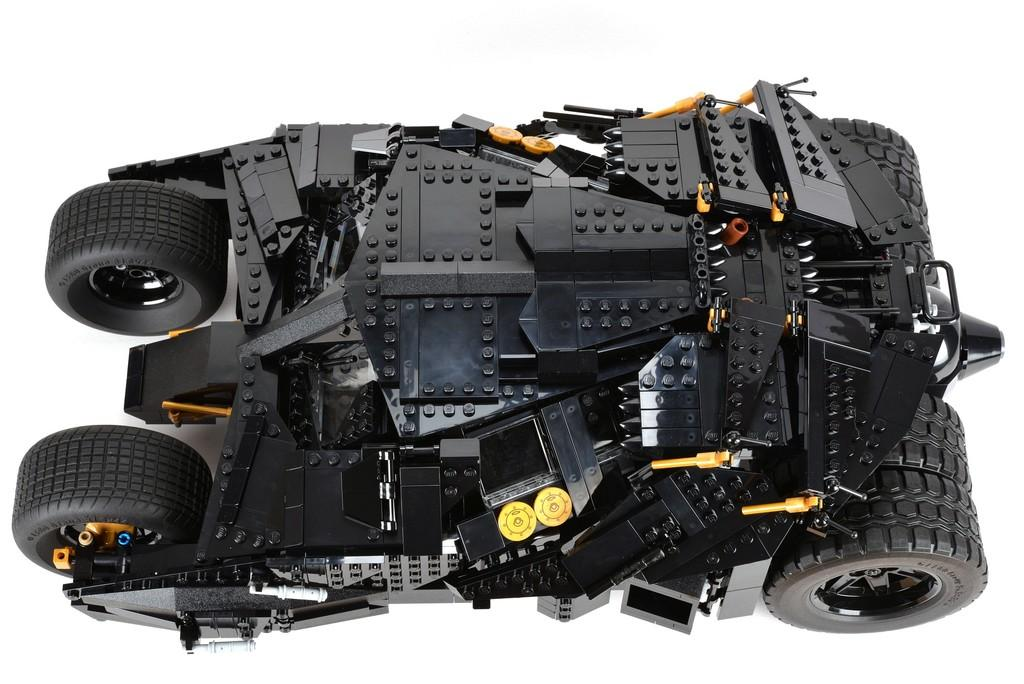What is the main subject of the image? The main subject of the image is a vehicle. What colors can be seen on the vehicle? The vehicle has black, yellow, and orange colors. What is the surface beneath the vehicle? The vehicle is on a white surface. What material is the vehicle made of? The vehicle is made of Lego, which is a toy. What is the reaction of the leg in the image when it sees the vehicle? There is no leg present in the image, so it is not possible to determine any reaction. 